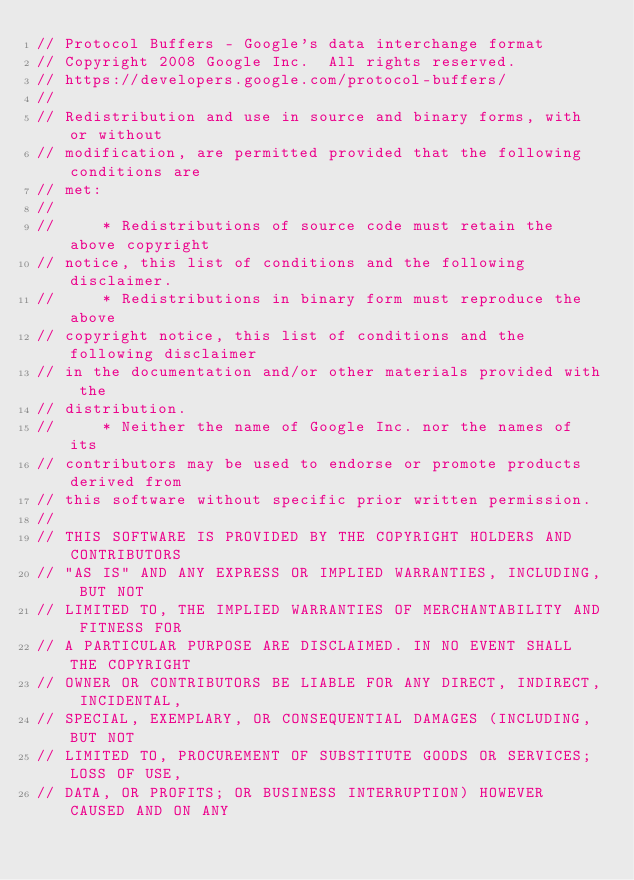Convert code to text. <code><loc_0><loc_0><loc_500><loc_500><_Go_>// Protocol Buffers - Google's data interchange format
// Copyright 2008 Google Inc.  All rights reserved.
// https://developers.google.com/protocol-buffers/
//
// Redistribution and use in source and binary forms, with or without
// modification, are permitted provided that the following conditions are
// met:
//
//     * Redistributions of source code must retain the above copyright
// notice, this list of conditions and the following disclaimer.
//     * Redistributions in binary form must reproduce the above
// copyright notice, this list of conditions and the following disclaimer
// in the documentation and/or other materials provided with the
// distribution.
//     * Neither the name of Google Inc. nor the names of its
// contributors may be used to endorse or promote products derived from
// this software without specific prior written permission.
//
// THIS SOFTWARE IS PROVIDED BY THE COPYRIGHT HOLDERS AND CONTRIBUTORS
// "AS IS" AND ANY EXPRESS OR IMPLIED WARRANTIES, INCLUDING, BUT NOT
// LIMITED TO, THE IMPLIED WARRANTIES OF MERCHANTABILITY AND FITNESS FOR
// A PARTICULAR PURPOSE ARE DISCLAIMED. IN NO EVENT SHALL THE COPYRIGHT
// OWNER OR CONTRIBUTORS BE LIABLE FOR ANY DIRECT, INDIRECT, INCIDENTAL,
// SPECIAL, EXEMPLARY, OR CONSEQUENTIAL DAMAGES (INCLUDING, BUT NOT
// LIMITED TO, PROCUREMENT OF SUBSTITUTE GOODS OR SERVICES; LOSS OF USE,
// DATA, OR PROFITS; OR BUSINESS INTERRUPTION) HOWEVER CAUSED AND ON ANY</code> 